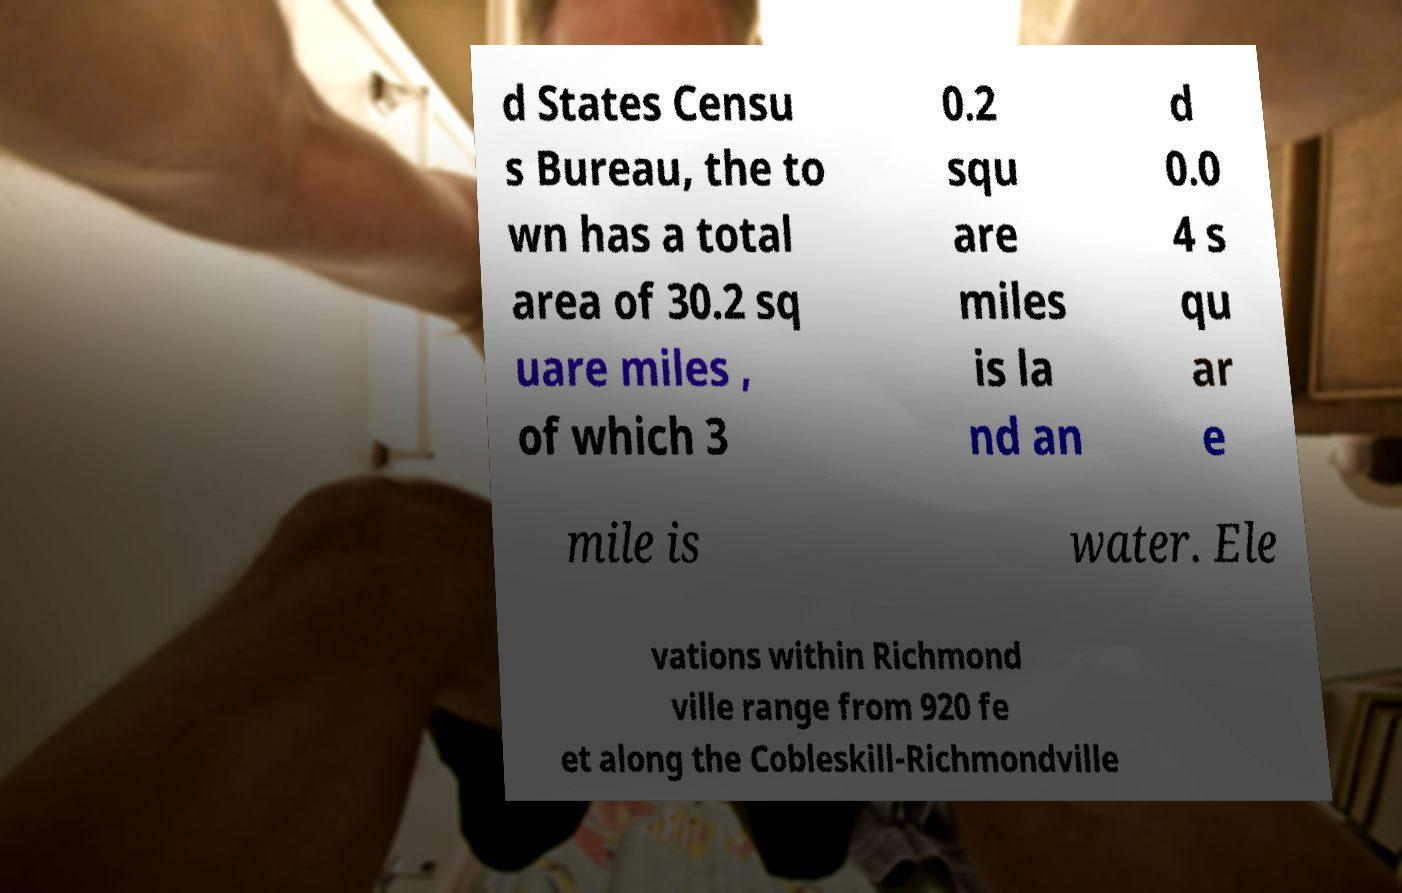There's text embedded in this image that I need extracted. Can you transcribe it verbatim? d States Censu s Bureau, the to wn has a total area of 30.2 sq uare miles , of which 3 0.2 squ are miles is la nd an d 0.0 4 s qu ar e mile is water. Ele vations within Richmond ville range from 920 fe et along the Cobleskill-Richmondville 